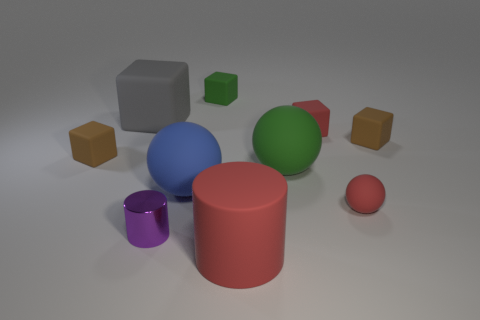There is a tiny thing that is the same color as the tiny sphere; what is its shape?
Provide a short and direct response. Cube. The small cylinder has what color?
Provide a succinct answer. Purple. What number of other objects are the same size as the blue matte ball?
Provide a succinct answer. 3. The large thing that is both to the right of the big blue thing and behind the small cylinder is made of what material?
Make the answer very short. Rubber. There is a brown cube on the right side of the red rubber ball; is it the same size as the big blue matte sphere?
Keep it short and to the point. No. Is the color of the big cylinder the same as the tiny matte sphere?
Give a very brief answer. Yes. How many large objects are both behind the large rubber cylinder and on the right side of the metal thing?
Your answer should be compact. 2. There is a tiny brown cube that is behind the rubber object on the left side of the large gray matte cube; how many tiny brown rubber things are on the left side of it?
Your answer should be compact. 1. What is the size of the cube that is the same color as the small ball?
Your answer should be very brief. Small. What is the shape of the tiny purple metal object?
Give a very brief answer. Cylinder. 